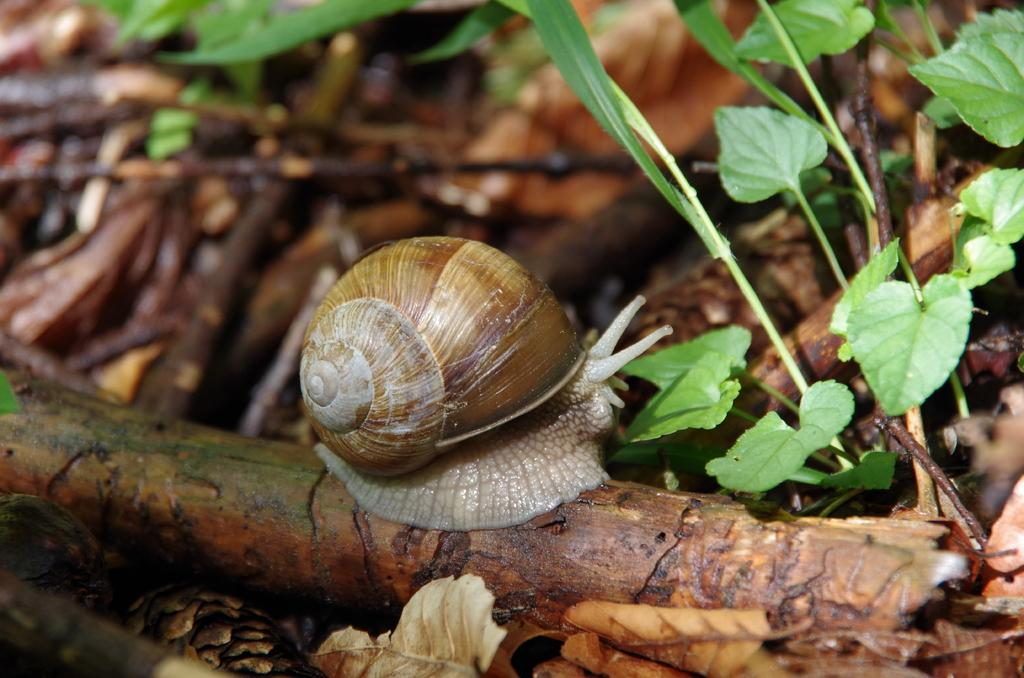What is the main subject of the image? There is a snail on a wooden stick in the image. What can be seen in the background of the image? There are plants with leaves in the background of the image. What else is visible in the image besides the snail and plants? There are sticks visible in the image. What type of vegetation can be seen on the ground in the image? Dried leaves are present on the land in the image. What type of coal is being used to fuel the boat in the image? There is no boat or coal present in the image; it features a snail on a wooden stick, plants, sticks, and dried leaves. 